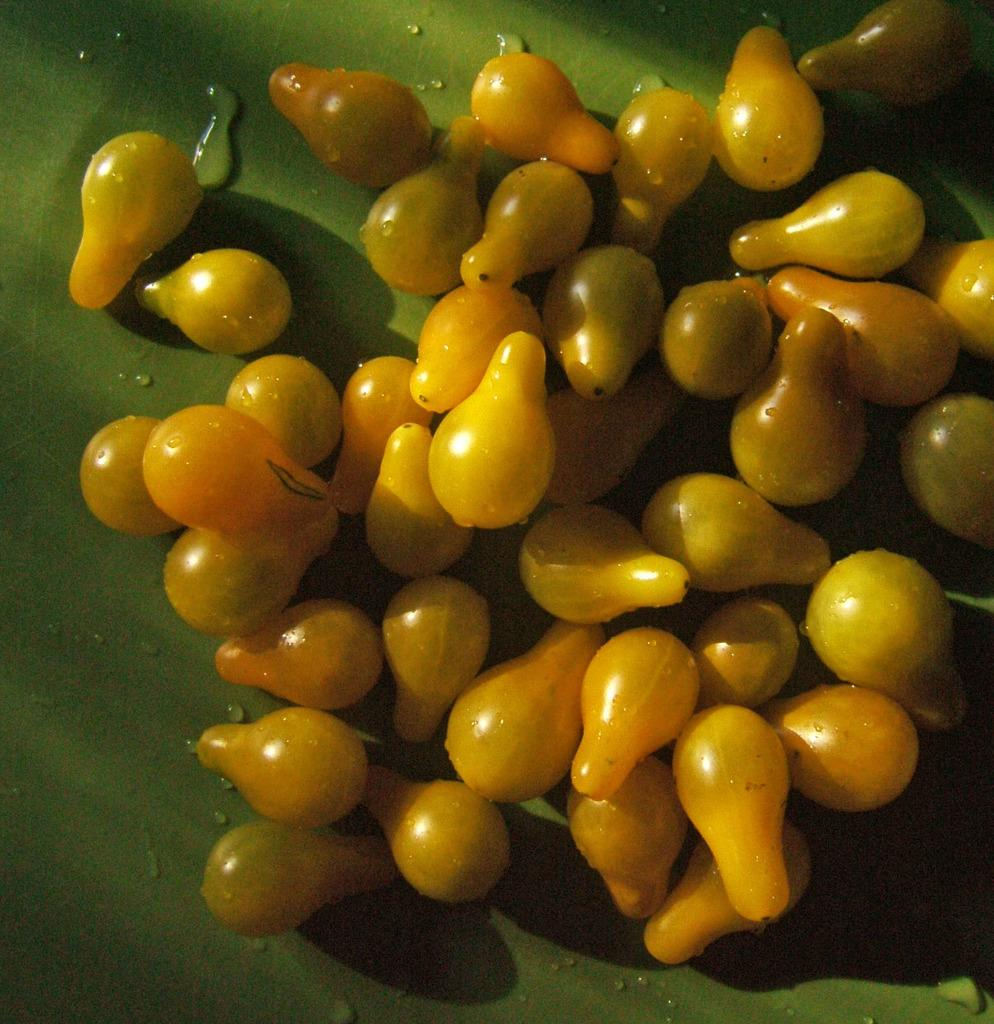What is located at the bottom of the image? There is a table at the bottom of the image. What can be found on the table? There are fruits on the table. What type of clocks are hanging on the wall in the image? There are no clocks visible in the image; it only features a table with fruits on it. 